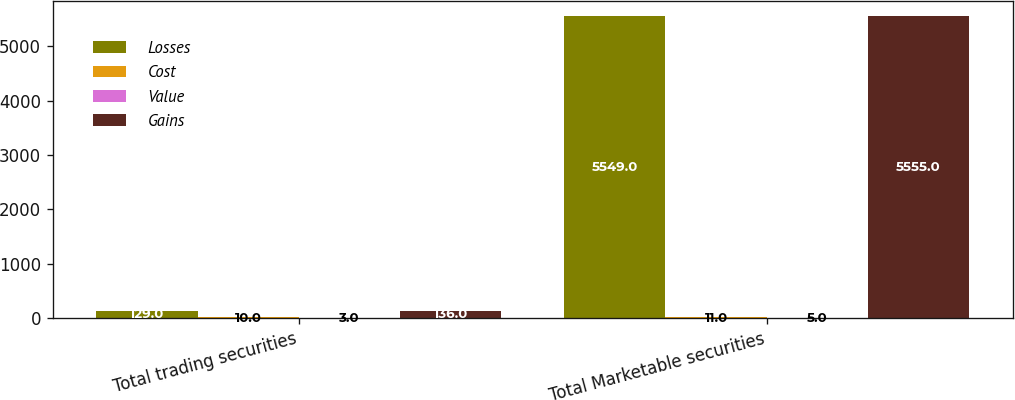<chart> <loc_0><loc_0><loc_500><loc_500><stacked_bar_chart><ecel><fcel>Total trading securities<fcel>Total Marketable securities<nl><fcel>Losses<fcel>129<fcel>5549<nl><fcel>Cost<fcel>10<fcel>11<nl><fcel>Value<fcel>3<fcel>5<nl><fcel>Gains<fcel>136<fcel>5555<nl></chart> 